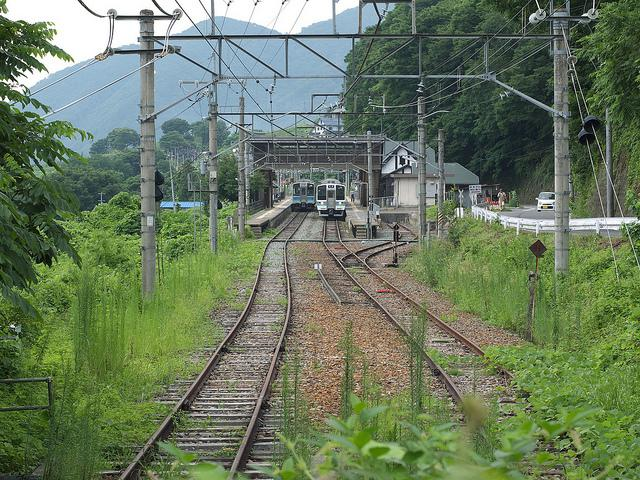How many trains could be traveling underneath of these wires overhanging the train track? Please explain your reasoning. two. Since there are only two pairs of tracksand this number of trains shown. 